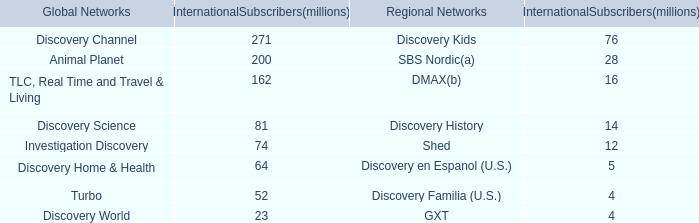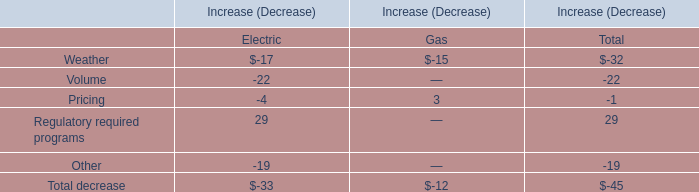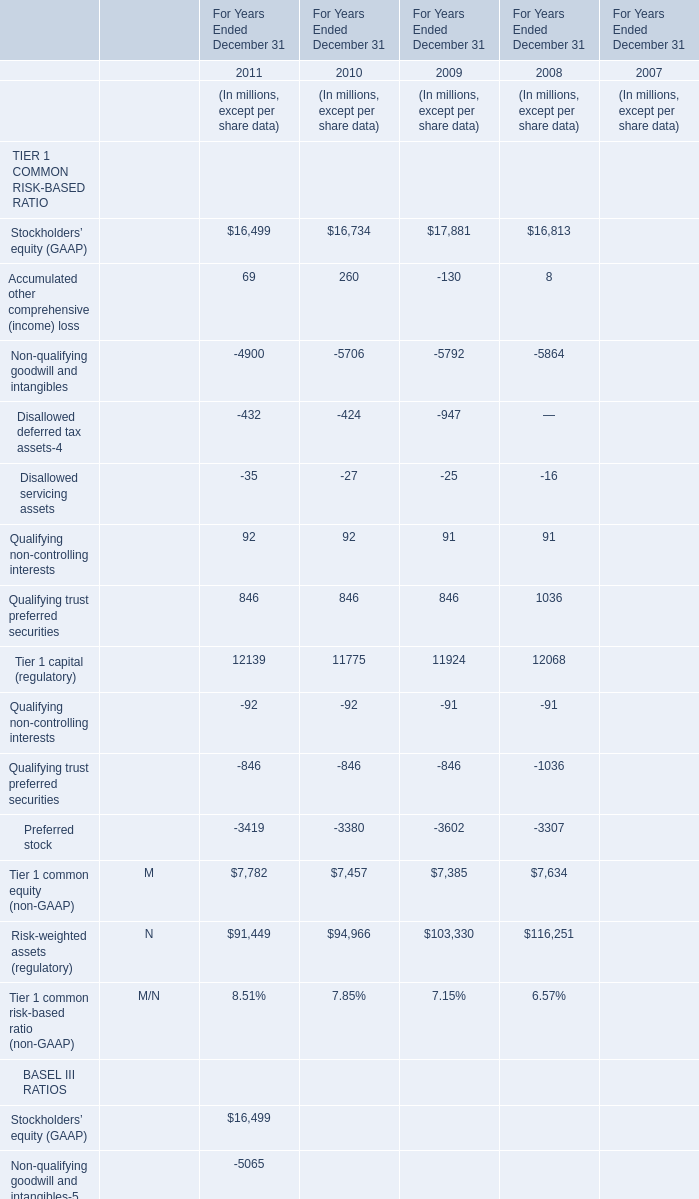What is the sum of Qualifying non-controlling interests in the range of 1 and 100 in 2011 and 2010? (in million) 
Computations: (92 + 92)
Answer: 184.0. 